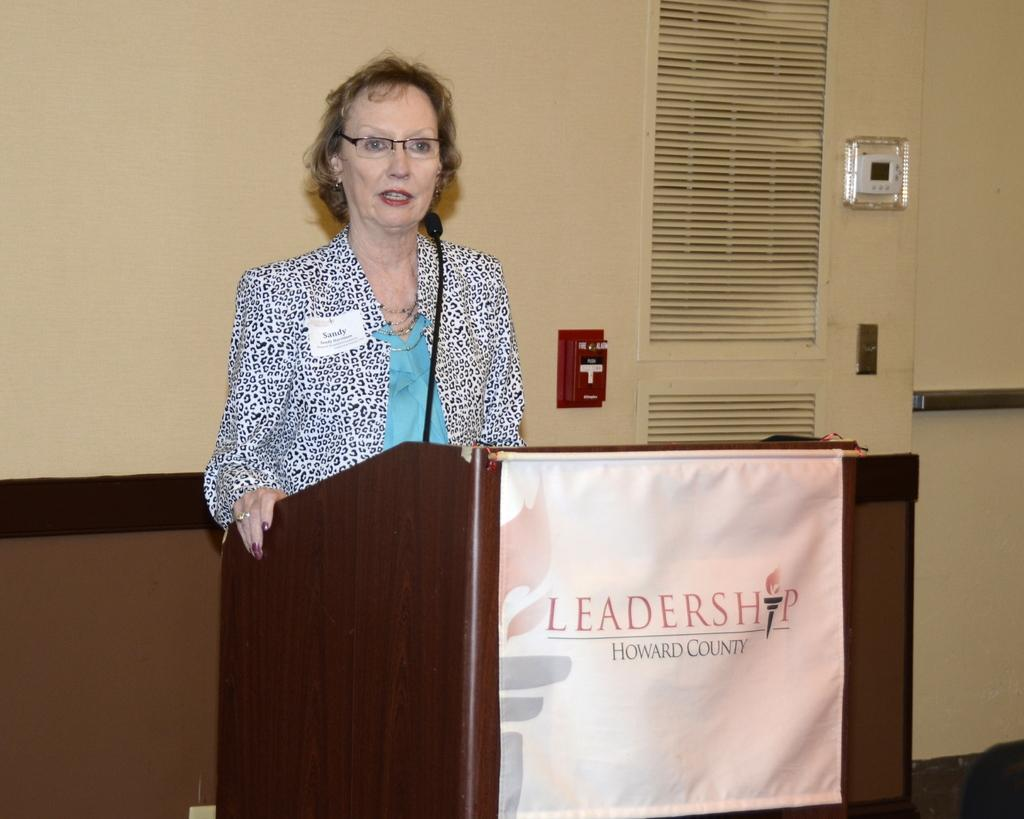Who is the main subject in the image? There is a woman in the image. What is the woman doing in the image? The woman is standing and speaking into a microphone. What can be seen in the background of the image? There is a wall in the background of the image. What type of jeans is the woman wearing in the image? The provided facts do not mention the woman's clothing, so we cannot determine if she is wearing jeans or any other type of clothing. 